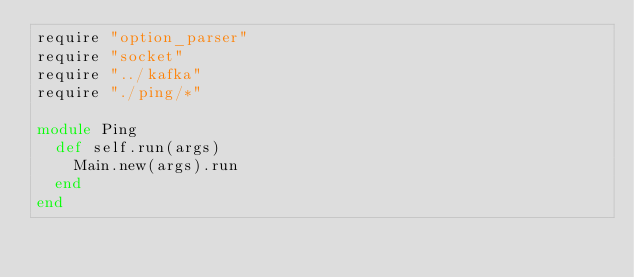Convert code to text. <code><loc_0><loc_0><loc_500><loc_500><_Crystal_>require "option_parser"
require "socket"
require "../kafka"
require "./ping/*"

module Ping
  def self.run(args)
    Main.new(args).run
  end
end
</code> 